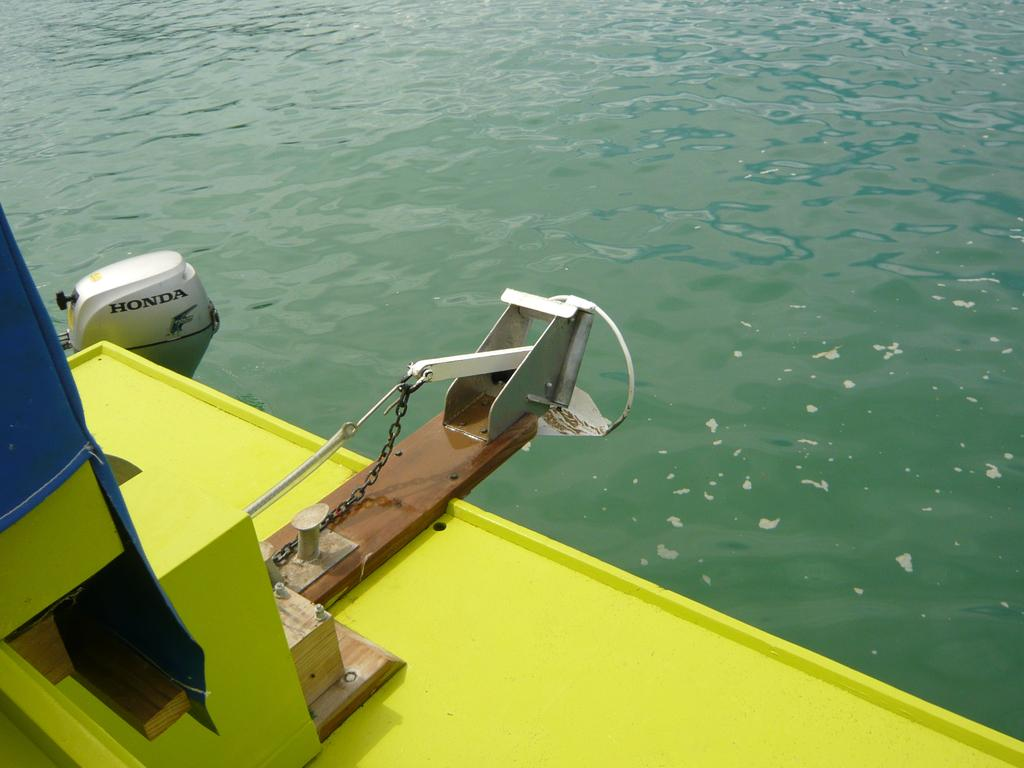What is located on the left side of the image? There is a boat on the left side of the image. What can be seen beside the boat? There is water beside the boat. How many marbles are floating in the water beside the boat? There are no marbles present in the image; it only features a boat and water. What type of animal can be seen grazing near the boat? There are no animals present in the image; it only features a boat and water. 